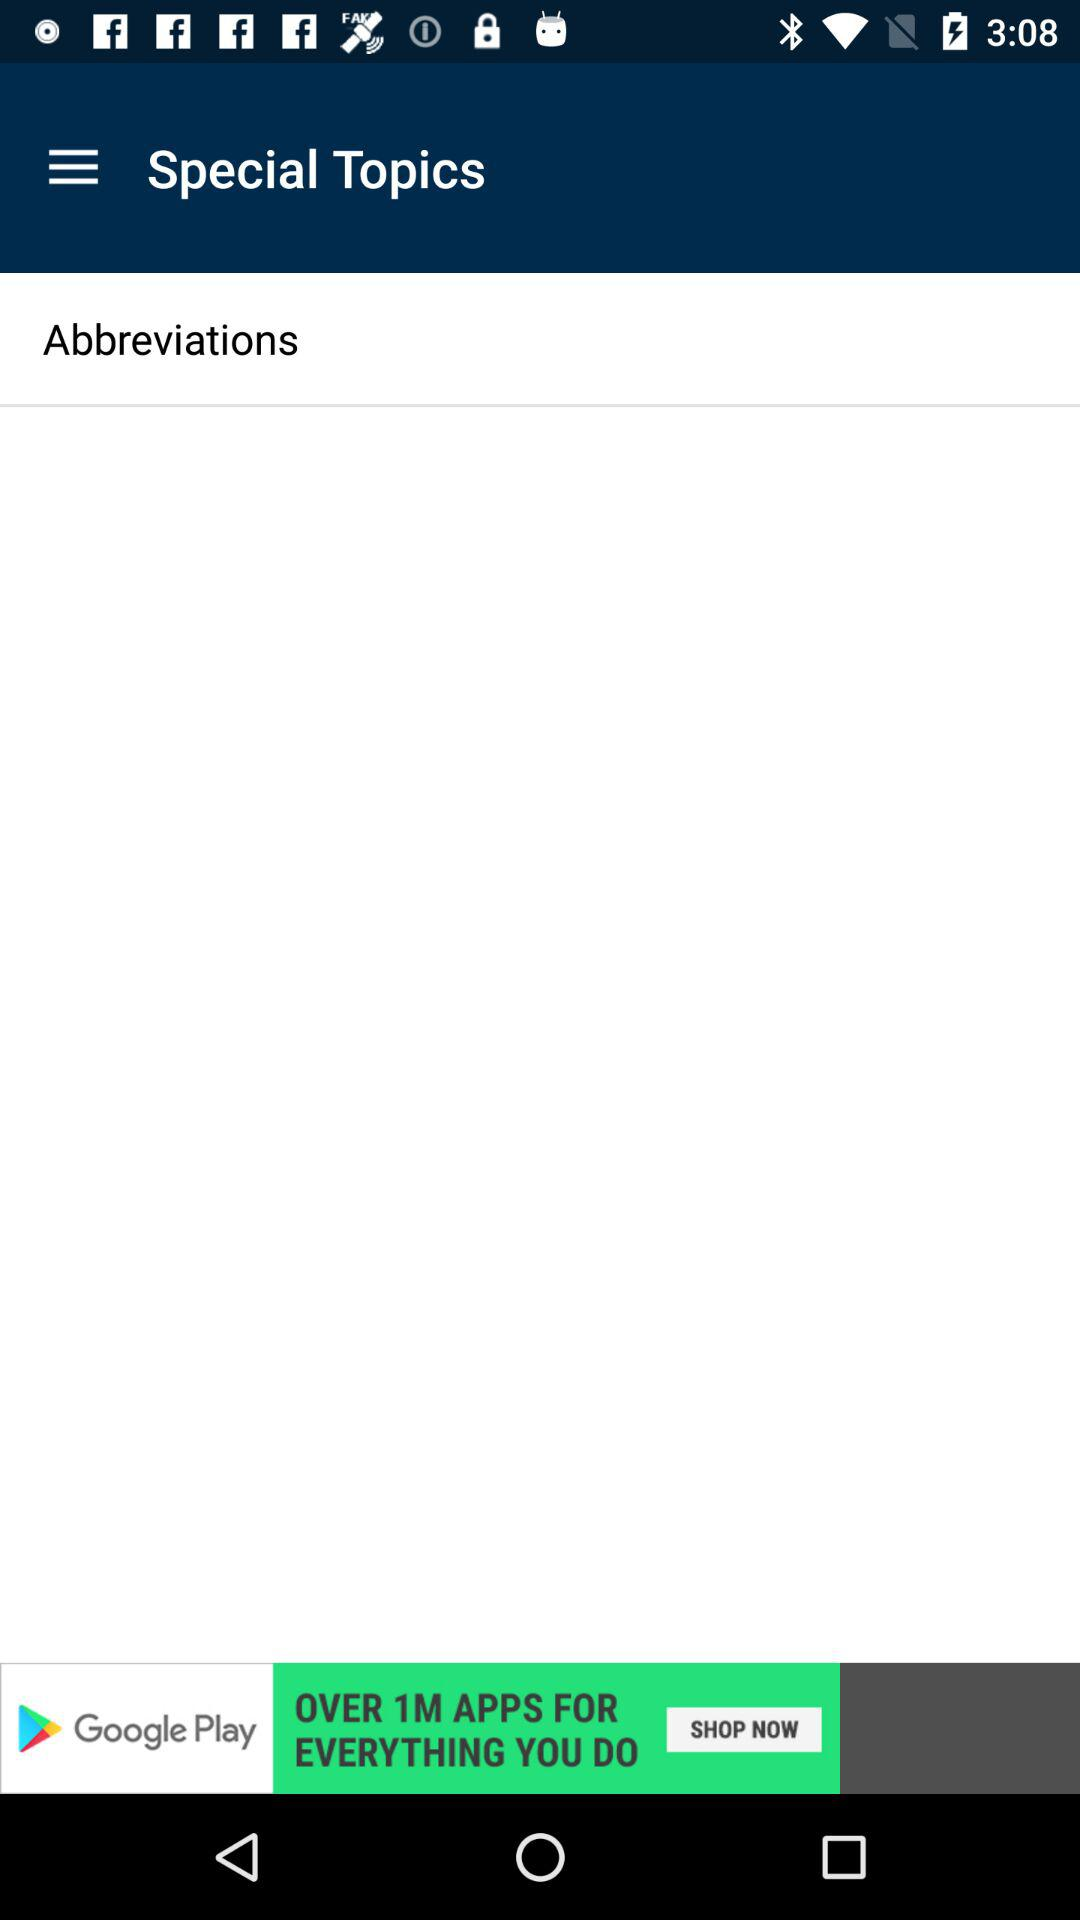What are the special topics? The special topic is "Abbreviations". 